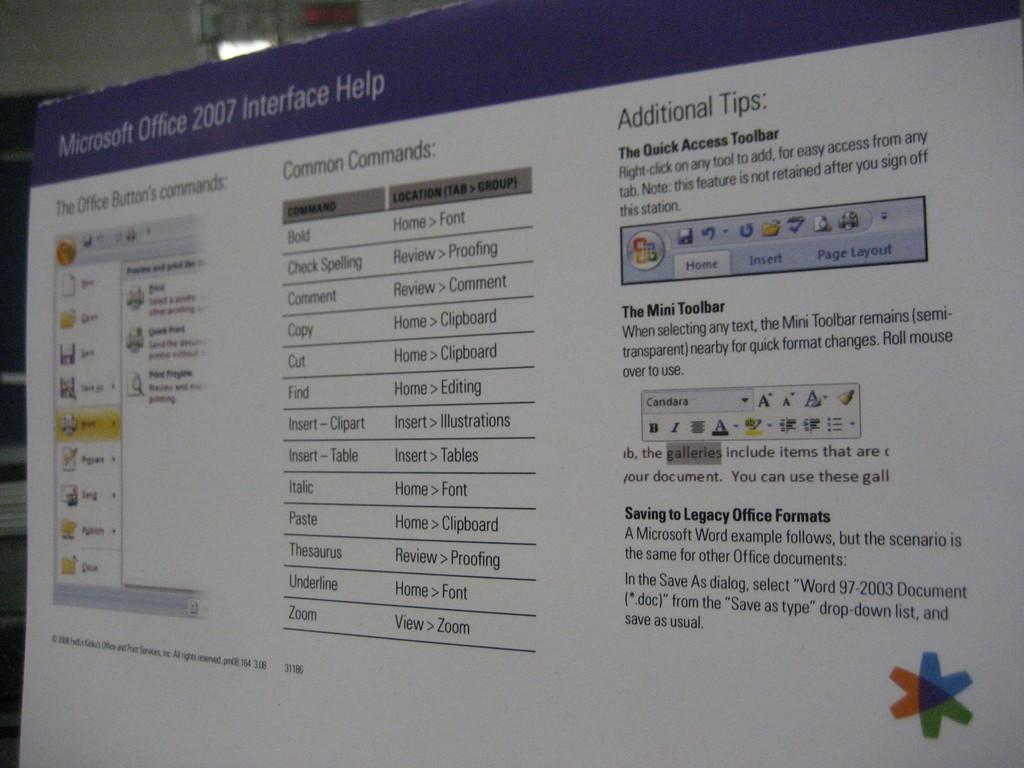<image>
Give a short and clear explanation of the subsequent image. A pster offering helpful tips for working with Microsoft Office 2007 